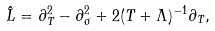Convert formula to latex. <formula><loc_0><loc_0><loc_500><loc_500>\hat { L } = \partial _ { T } ^ { 2 } - \partial _ { \sigma } ^ { 2 } + 2 ( T + \Lambda ) ^ { - 1 } \partial _ { T } ,</formula> 